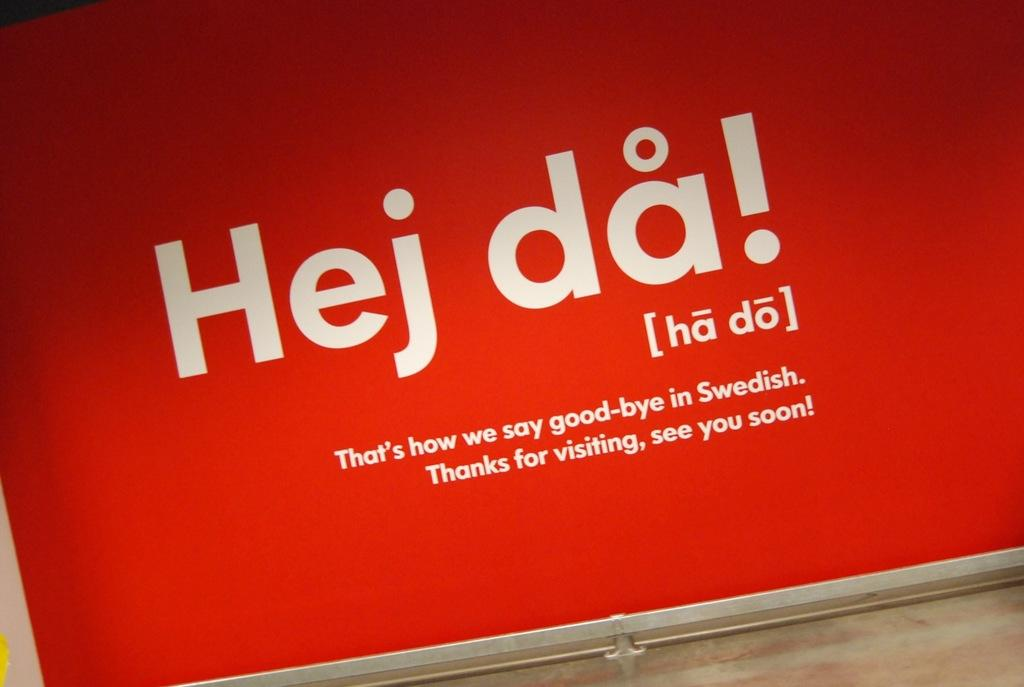<image>
Present a compact description of the photo's key features. Red background with white words that says "Hej da". 